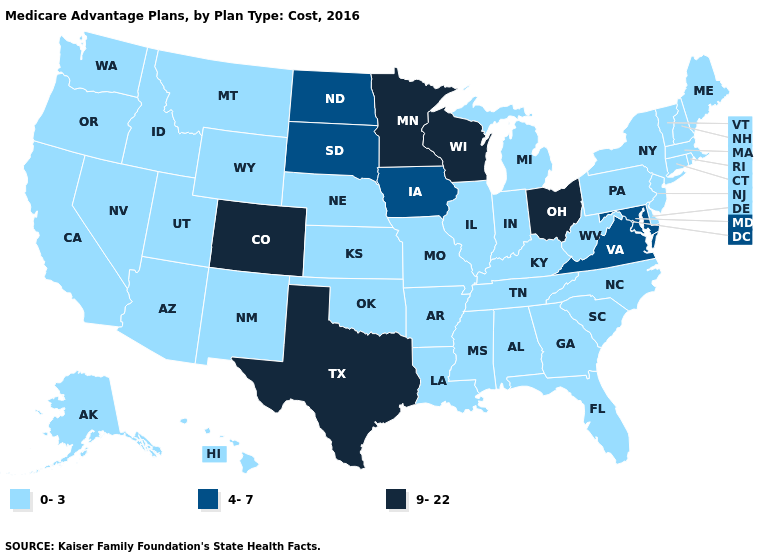Does the first symbol in the legend represent the smallest category?
Be succinct. Yes. Does the first symbol in the legend represent the smallest category?
Give a very brief answer. Yes. Name the states that have a value in the range 4-7?
Answer briefly. Iowa, Maryland, North Dakota, South Dakota, Virginia. Does Alaska have the highest value in the West?
Be succinct. No. What is the value of Nebraska?
Answer briefly. 0-3. Among the states that border Virginia , does West Virginia have the lowest value?
Answer briefly. Yes. Which states hav the highest value in the Northeast?
Keep it brief. Connecticut, Massachusetts, Maine, New Hampshire, New Jersey, New York, Pennsylvania, Rhode Island, Vermont. What is the highest value in states that border California?
Answer briefly. 0-3. What is the value of Idaho?
Give a very brief answer. 0-3. What is the value of Connecticut?
Short answer required. 0-3. What is the value of North Carolina?
Keep it brief. 0-3. Name the states that have a value in the range 0-3?
Answer briefly. Alaska, Alabama, Arkansas, Arizona, California, Connecticut, Delaware, Florida, Georgia, Hawaii, Idaho, Illinois, Indiana, Kansas, Kentucky, Louisiana, Massachusetts, Maine, Michigan, Missouri, Mississippi, Montana, North Carolina, Nebraska, New Hampshire, New Jersey, New Mexico, Nevada, New York, Oklahoma, Oregon, Pennsylvania, Rhode Island, South Carolina, Tennessee, Utah, Vermont, Washington, West Virginia, Wyoming. What is the value of Maryland?
Give a very brief answer. 4-7. What is the value of Iowa?
Write a very short answer. 4-7. 